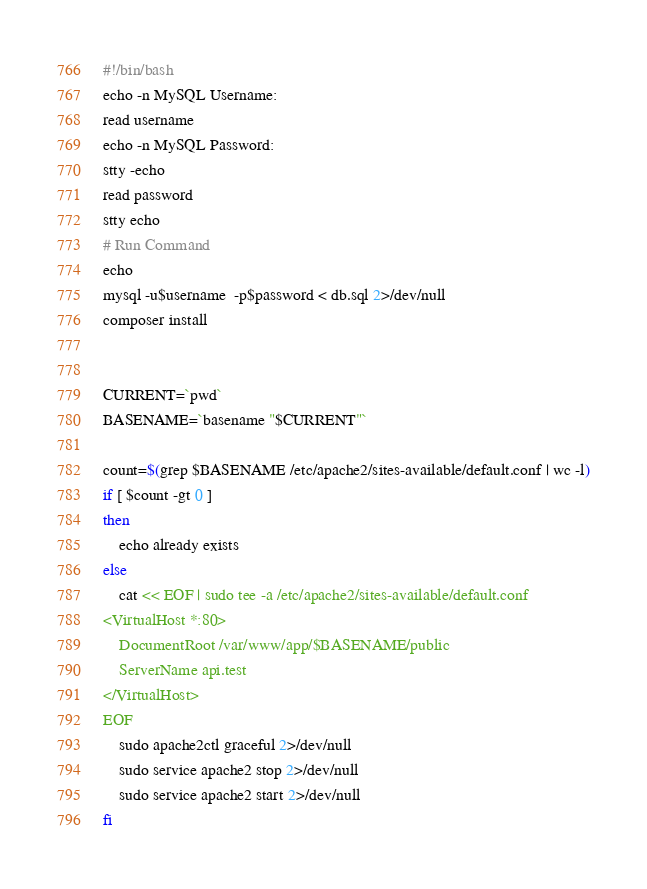Convert code to text. <code><loc_0><loc_0><loc_500><loc_500><_Bash_>#!/bin/bash
echo -n MySQL Username:
read username
echo -n MySQL Password:
stty -echo
read password
stty echo
# Run Command
echo
mysql -u$username  -p$password < db.sql 2>/dev/null
composer install


CURRENT=`pwd`
BASENAME=`basename "$CURRENT"`

count=$(grep $BASENAME /etc/apache2/sites-available/default.conf | wc -l)
if [ $count -gt 0 ]
then
    echo already exists
else
    cat << EOF | sudo tee -a /etc/apache2/sites-available/default.conf
<VirtualHost *:80>
    DocumentRoot /var/www/app/$BASENAME/public
    ServerName api.test
</VirtualHost>
EOF
    sudo apache2ctl graceful 2>/dev/null
    sudo service apache2 stop 2>/dev/null
    sudo service apache2 start 2>/dev/null
fi
</code> 